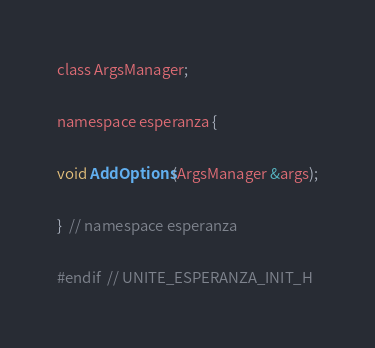Convert code to text. <code><loc_0><loc_0><loc_500><loc_500><_C_>class ArgsManager;

namespace esperanza {

void AddOptions(ArgsManager &args);

}  // namespace esperanza

#endif  // UNITE_ESPERANZA_INIT_H
</code> 